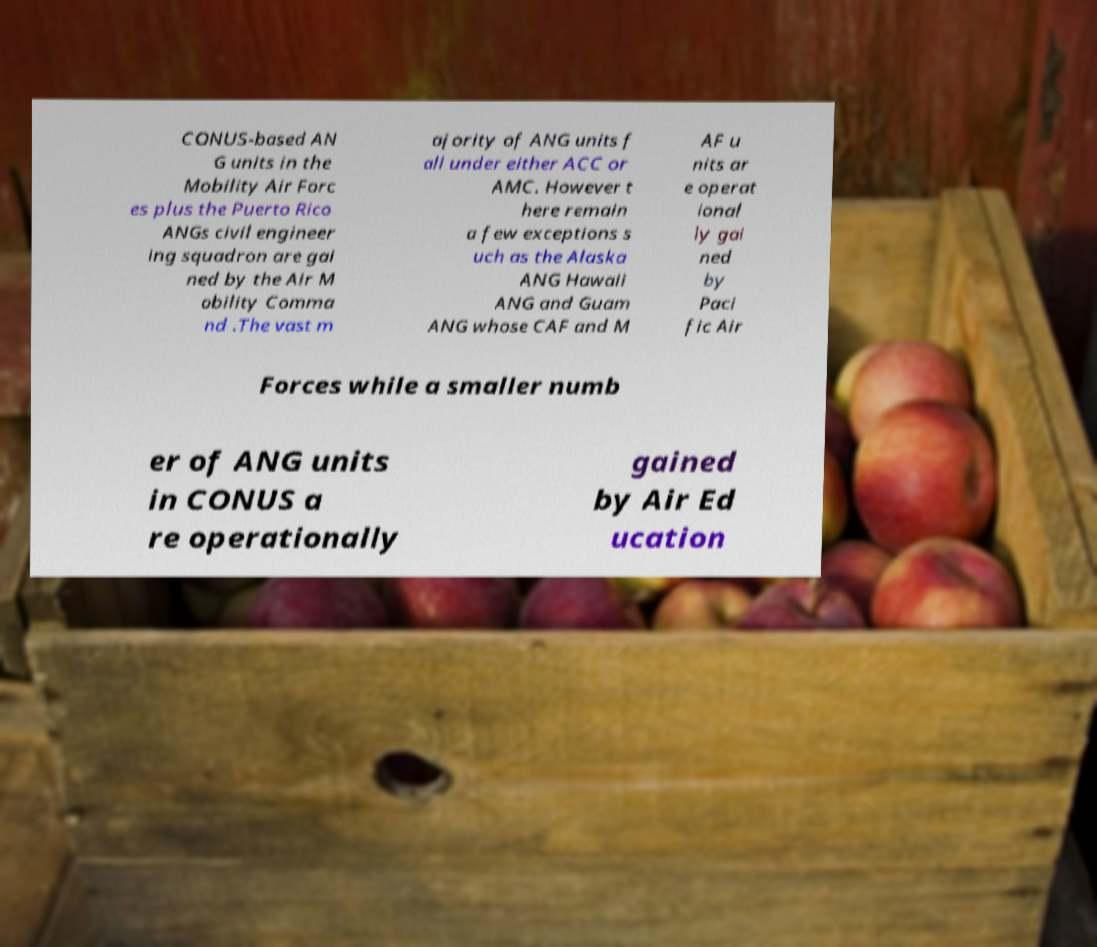I need the written content from this picture converted into text. Can you do that? CONUS-based AN G units in the Mobility Air Forc es plus the Puerto Rico ANGs civil engineer ing squadron are gai ned by the Air M obility Comma nd .The vast m ajority of ANG units f all under either ACC or AMC. However t here remain a few exceptions s uch as the Alaska ANG Hawaii ANG and Guam ANG whose CAF and M AF u nits ar e operat ional ly gai ned by Paci fic Air Forces while a smaller numb er of ANG units in CONUS a re operationally gained by Air Ed ucation 